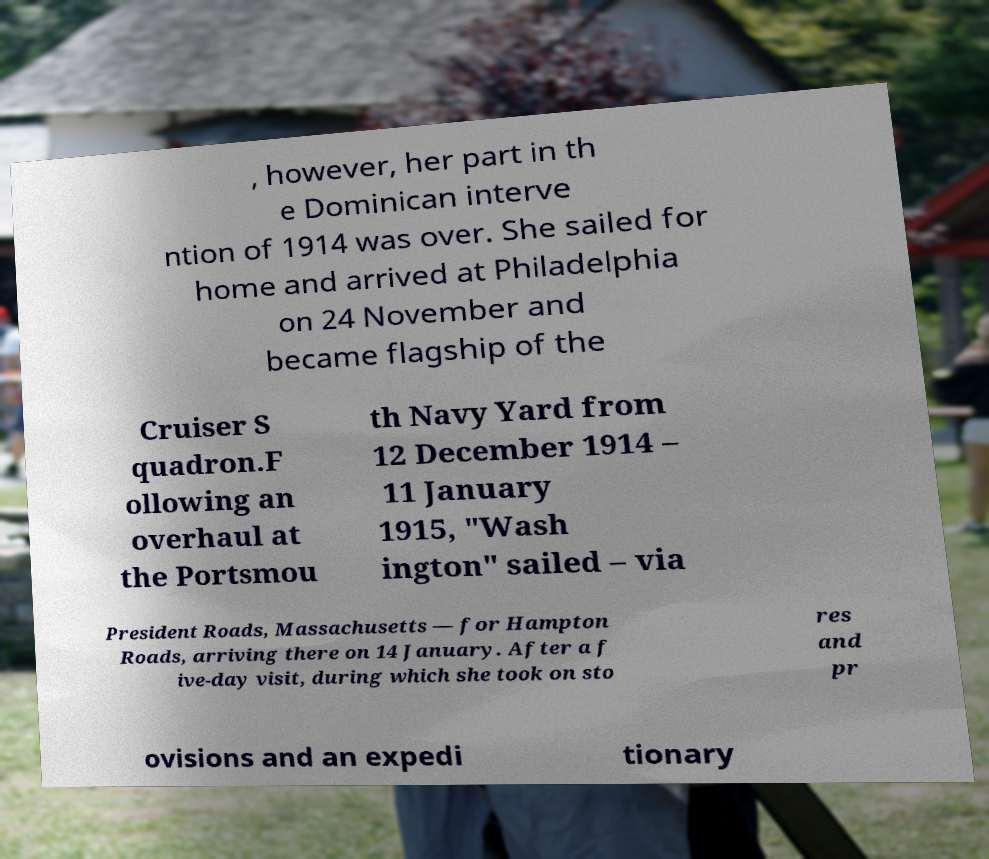Could you extract and type out the text from this image? , however, her part in th e Dominican interve ntion of 1914 was over. She sailed for home and arrived at Philadelphia on 24 November and became flagship of the Cruiser S quadron.F ollowing an overhaul at the Portsmou th Navy Yard from 12 December 1914 – 11 January 1915, "Wash ington" sailed – via President Roads, Massachusetts — for Hampton Roads, arriving there on 14 January. After a f ive-day visit, during which she took on sto res and pr ovisions and an expedi tionary 